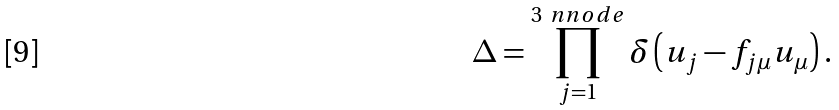<formula> <loc_0><loc_0><loc_500><loc_500>\Delta = \prod _ { j = 1 } ^ { 3 \ n n o d e } \delta \left ( u _ { j } - f _ { j \mu } u _ { \mu } \right ) .</formula> 